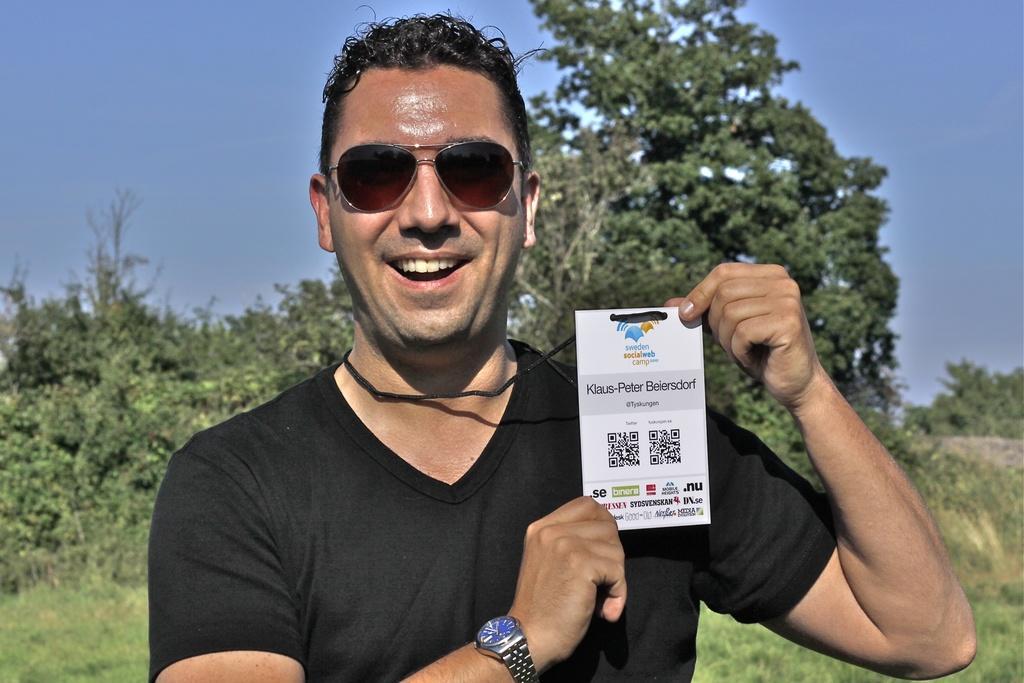Please provide a concise description of this image. In this image we can see a person wearing specs and watch is holding a tag. In the back there are trees and sky. 